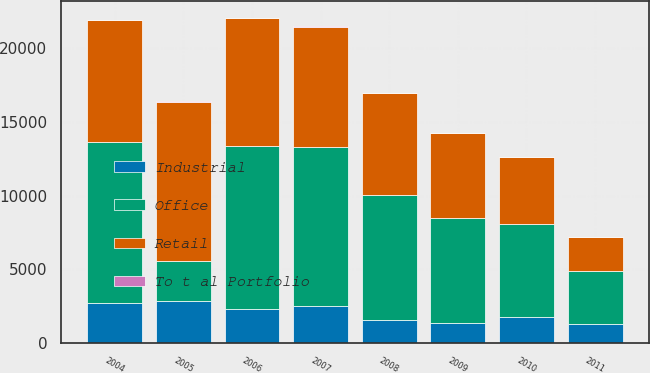Convert chart to OTSL. <chart><loc_0><loc_0><loc_500><loc_500><stacked_bar_chart><ecel><fcel>2004<fcel>2005<fcel>2006<fcel>2007<fcel>2008<fcel>2009<fcel>2010<fcel>2011<nl><fcel>Office<fcel>10963<fcel>2692<fcel>11045<fcel>10771<fcel>8491<fcel>7135<fcel>6312<fcel>3600<nl><fcel>Retail<fcel>8248<fcel>10828<fcel>8725<fcel>8199<fcel>6912<fcel>5776<fcel>4511<fcel>2325<nl><fcel>Industrial<fcel>2692<fcel>2861<fcel>2315<fcel>2514<fcel>1555<fcel>1340<fcel>1785<fcel>1259<nl><fcel>To t al Portfolio<fcel>23<fcel>38<fcel>5<fcel>58<fcel>24<fcel>19<fcel>16<fcel>16<nl></chart> 